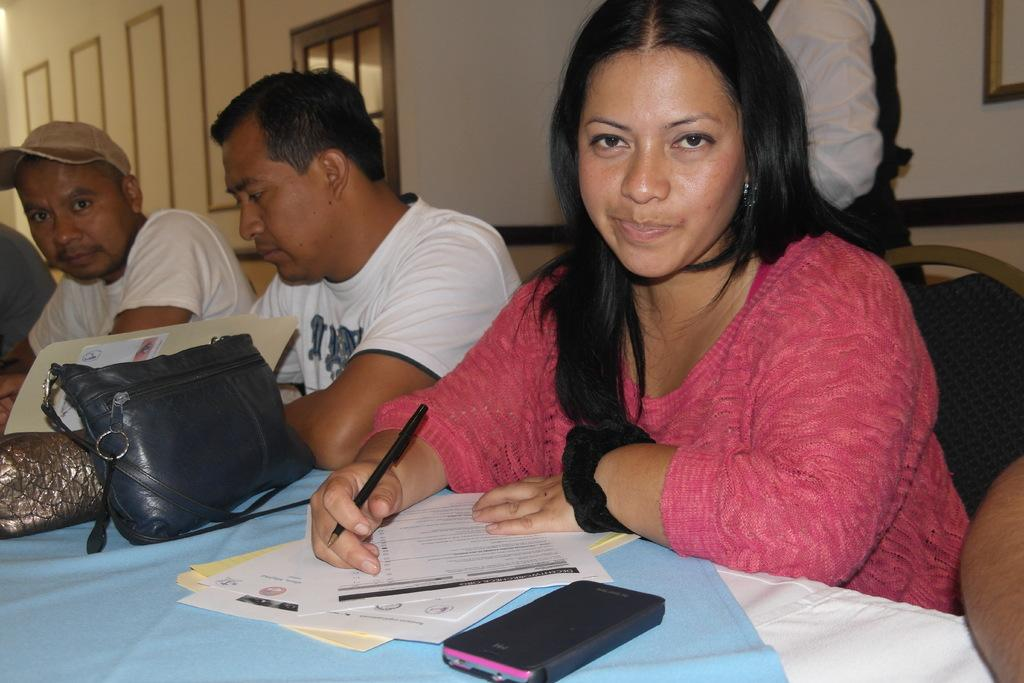How many people are sitting in the image? There are three persons sitting on chairs in the image. What is the main piece of furniture in the image? There is a table in the image. What items can be seen on the table? Papers, a mobile, and a bag are present on the table. What is visible in the background of the image? There is a wall in the background of the image. What time does the clock show in the image? There is no clock present in the image, so it is not possible to determine the time. 